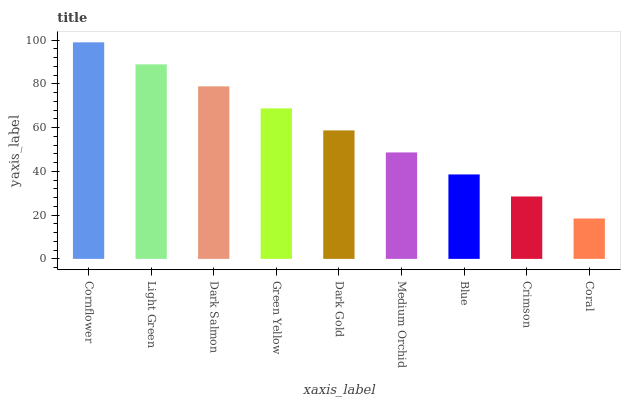Is Coral the minimum?
Answer yes or no. Yes. Is Cornflower the maximum?
Answer yes or no. Yes. Is Light Green the minimum?
Answer yes or no. No. Is Light Green the maximum?
Answer yes or no. No. Is Cornflower greater than Light Green?
Answer yes or no. Yes. Is Light Green less than Cornflower?
Answer yes or no. Yes. Is Light Green greater than Cornflower?
Answer yes or no. No. Is Cornflower less than Light Green?
Answer yes or no. No. Is Dark Gold the high median?
Answer yes or no. Yes. Is Dark Gold the low median?
Answer yes or no. Yes. Is Dark Salmon the high median?
Answer yes or no. No. Is Coral the low median?
Answer yes or no. No. 